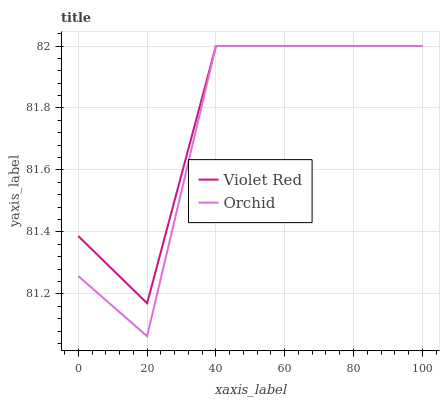Does Orchid have the minimum area under the curve?
Answer yes or no. Yes. Does Violet Red have the maximum area under the curve?
Answer yes or no. Yes. Does Orchid have the maximum area under the curve?
Answer yes or no. No. Is Violet Red the smoothest?
Answer yes or no. Yes. Is Orchid the roughest?
Answer yes or no. Yes. Is Orchid the smoothest?
Answer yes or no. No. Does Orchid have the lowest value?
Answer yes or no. Yes. Does Orchid have the highest value?
Answer yes or no. Yes. Does Orchid intersect Violet Red?
Answer yes or no. Yes. Is Orchid less than Violet Red?
Answer yes or no. No. Is Orchid greater than Violet Red?
Answer yes or no. No. 